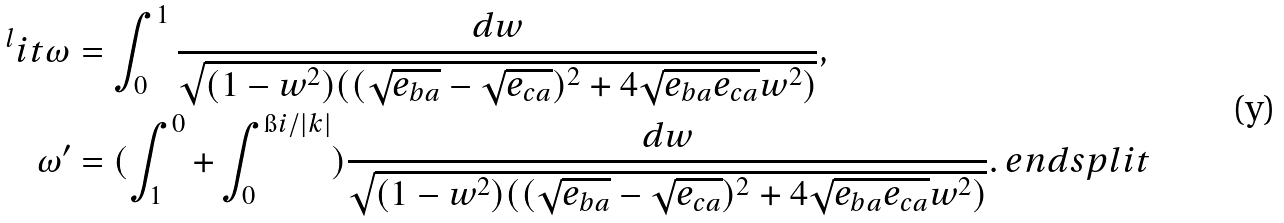Convert formula to latex. <formula><loc_0><loc_0><loc_500><loc_500>^ { l } i t \omega & = \int ^ { 1 } _ { 0 } \frac { d w } { \sqrt { ( 1 - w ^ { 2 } ) ( ( \sqrt { e _ { b a } } - \sqrt { e _ { c a } } ) ^ { 2 } + 4 \sqrt { e _ { b a } e _ { c a } } w ^ { 2 } ) } } , \\ \omega ^ { \prime } & = ( \int ^ { 0 } _ { 1 } + \int _ { 0 } ^ { \i i / | k | } ) \frac { d w } { \sqrt { ( 1 - w ^ { 2 } ) ( ( \sqrt { e _ { b a } } - \sqrt { e _ { c a } } ) ^ { 2 } + 4 \sqrt { e _ { b a } e _ { c a } } w ^ { 2 } ) } } . \ e n d s p l i t</formula> 